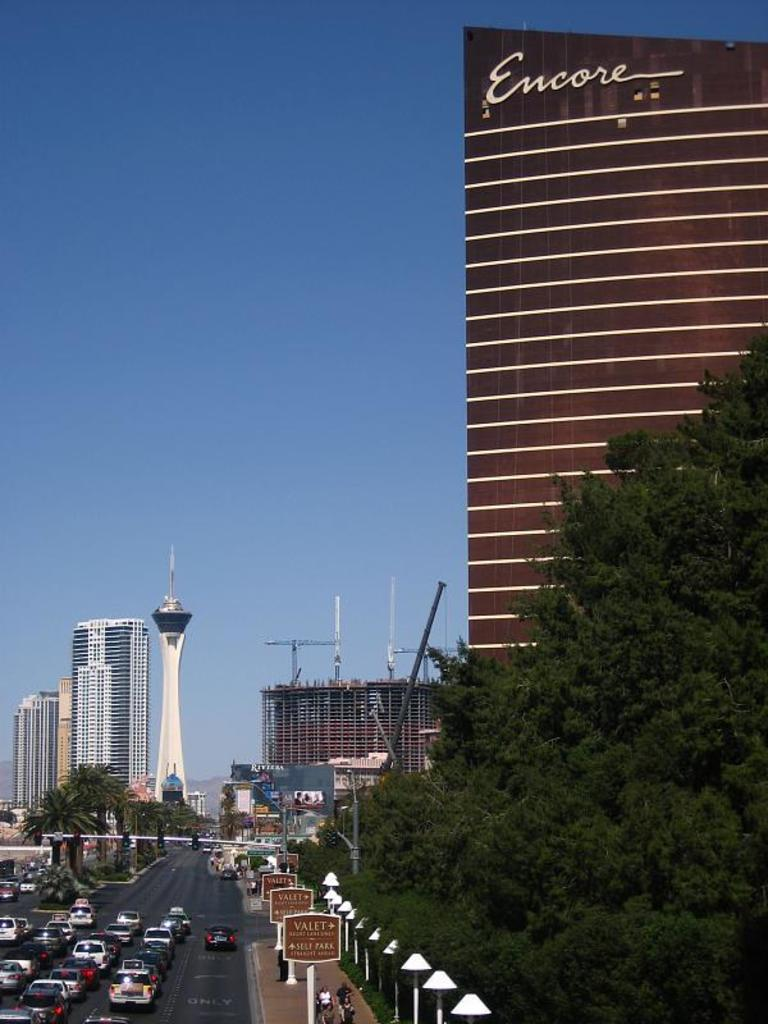What can be seen on the road in the image? There are vehicles on the road in the image. What objects are present in the image besides the vehicles? There are boards, poles, lights, buildings, trees, and the sky visible in the image. Can you describe the poles in the image? The poles are vertical structures that can be used for various purposes, such as holding signs or lights. What type of structures can be seen in the image? There are buildings in the image. What natural elements are present in the image? There are trees and the sky visible in the image. Where is the daughter playing in the image? There is no daughter present in the image. What type of island can be seen in the image? There is no island present in the image. 